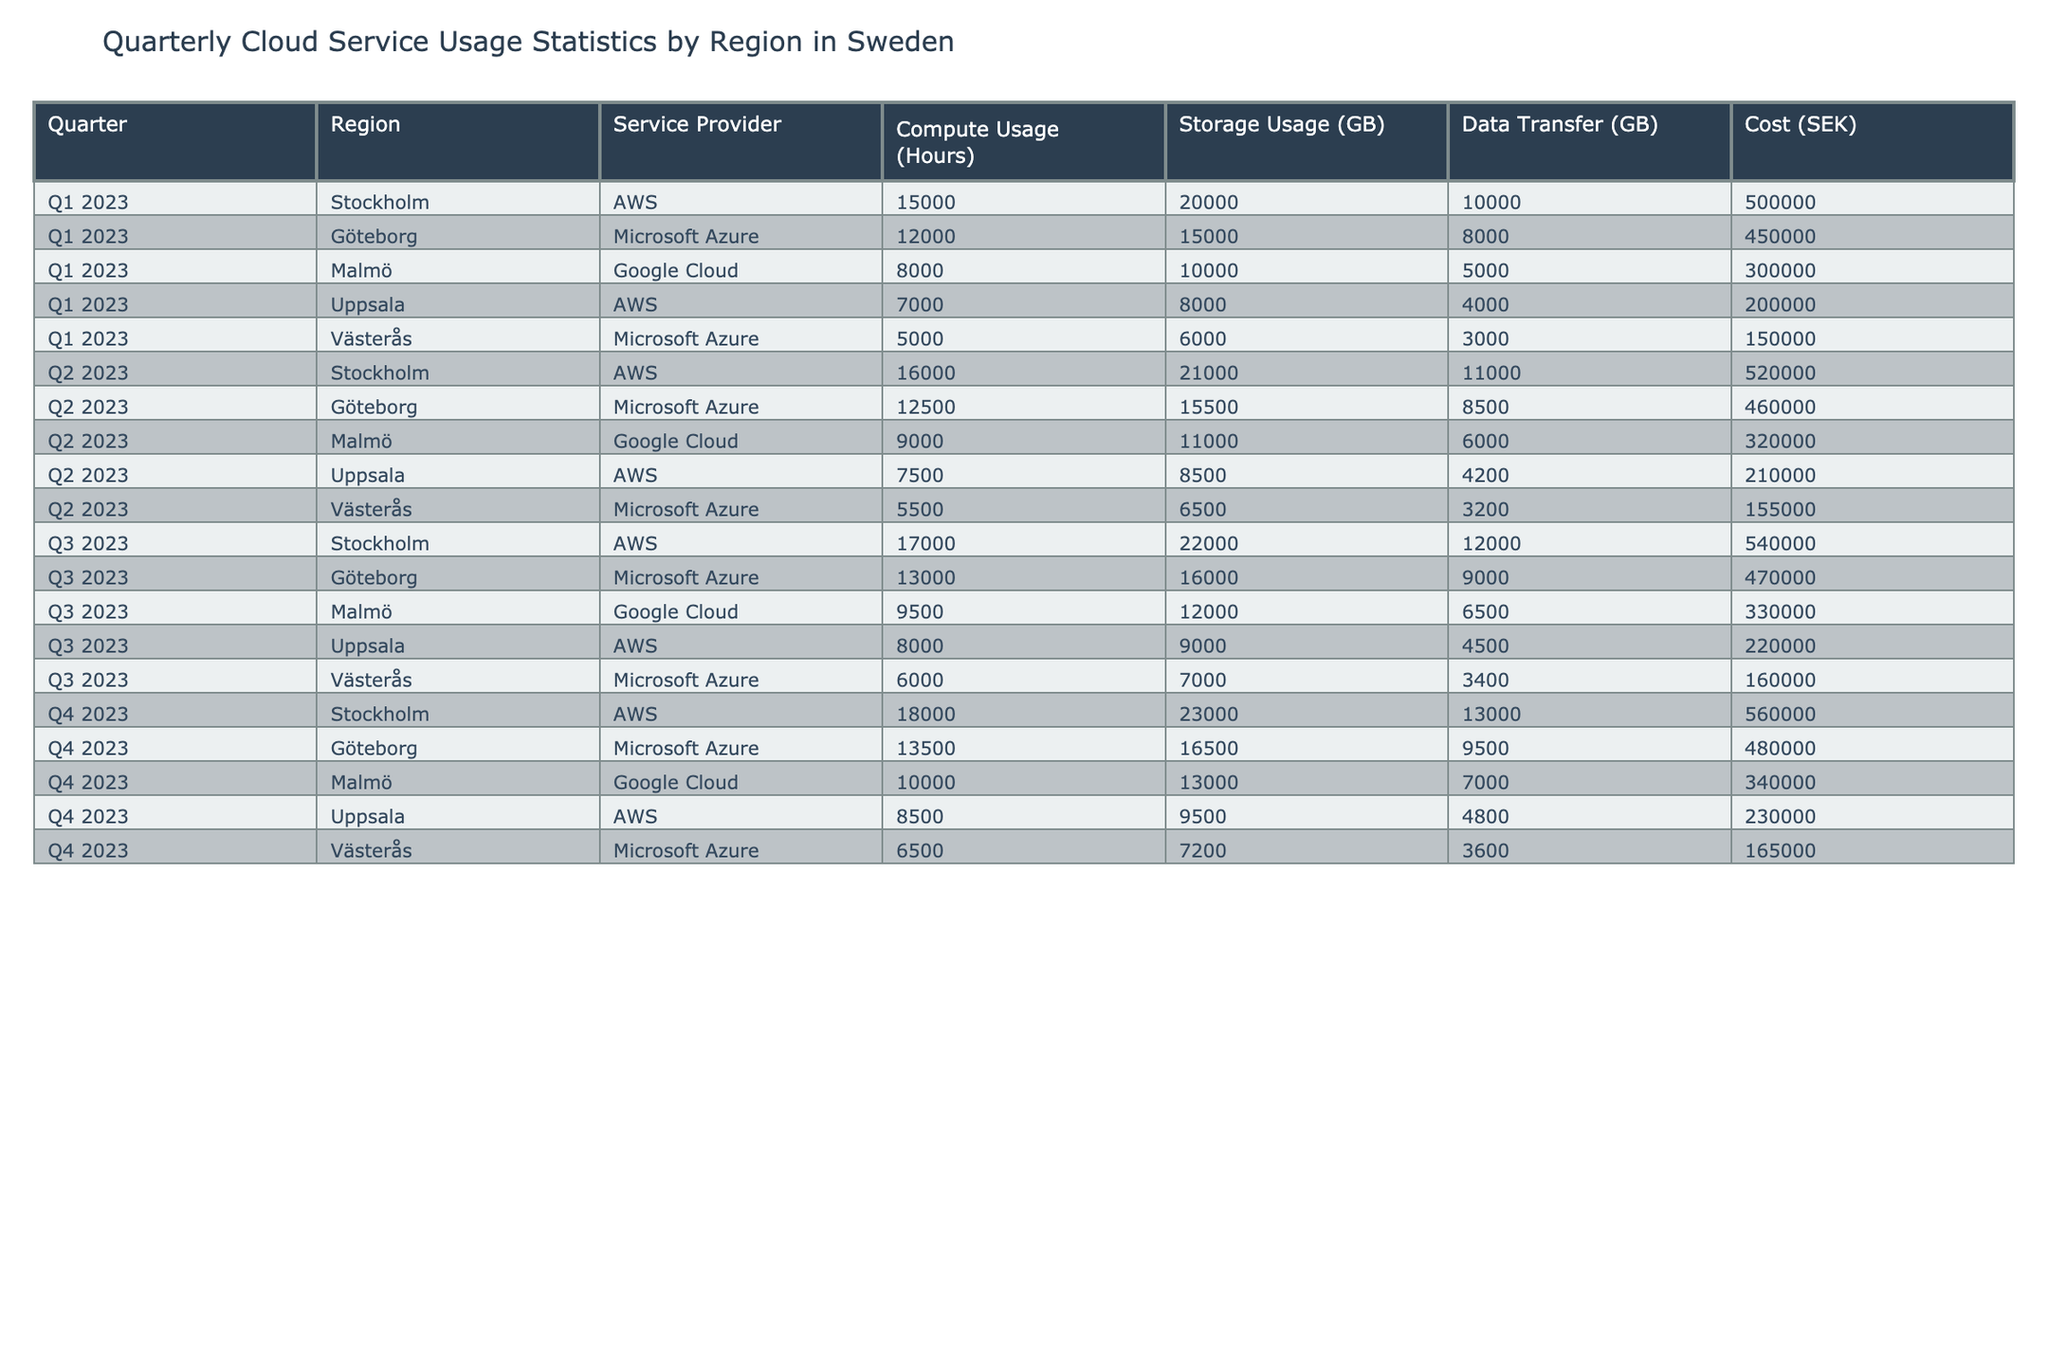What was the compute usage (in hours) for AWS in Q3 2023 in Stockholm? Referring to the table, the specific entry for compute usage under AWS in the Stockholm region for Q3 2023 is 17,000 hours.
Answer: 17,000 Which region had the highest data transfer (in GB) in Q4 2023? From the table, looking at the data transfer values in Q4 2023, Stockholm had 13,000 GB, which is the highest compared to other regions.
Answer: Stockholm What is the total cost (in SEK) for Microsoft Azure services across all regions in Q2 2023? For Microsoft Azure in Q2 2023, the costs are 460,000 SEK (Göteborg) + 155,000 SEK (Västerås) = 615,000 SEK.
Answer: 615,000 How much more compute usage (in hours) did AWS have in Q4 2023 compared to Q1 2023 in Stockholm? In Q4 2023, AWS had 18,000 hours of compute usage, and in Q1 2023, they had 15,000 hours. The difference is 18,000 - 15,000 = 3,000 hours.
Answer: 3,000 Is the storage usage (in GB) for Google Cloud in Malmö in Q3 2023 greater than the storage usage in Q1 2023? In Q3 2023, the storage usage for Google Cloud in Malmö was 12,000 GB, compared to 10,000 GB in Q1 2023. Therefore, the statement is true.
Answer: Yes What was the average data transfer (in GB) for Microsoft Azure across all quarters in Göteborg? In Göteborg, Microsoft Azure's data transfer values are: 8,500 GB (Q1) + 8,000 GB (Q2) + 9,000 GB (Q3) + 9,500 GB (Q4). The total is 35,000 GB, and the average is 35,000 / 4 = 8,750 GB.
Answer: 8,750 Which region showed the largest increase in cost (in SEK) from Q1 2023 to Q4 2023 for AWS? For AWS, the costs were 500,000 SEK in Q1 2023 (Stockholm) and 560,000 SEK in Q4 2023, a difference of 60,000 SEK. Other regions also increased, but Stockholm had the largest increase.
Answer: Stockholm Was the total compute usage (in hours) for all service providers in Uppsala greater in Q3 2023 than in Q2 2023? In Q3 2023, compute usage in Uppsala was 8,000 hours and in Q2 2023, it was 7,500 hours. Therefore, Q3 had a higher usage.
Answer: Yes What region had the lowest storage usage (in GB) in Q1 2023? In Q1 2023, Västerås had the lowest storage usage at 6,000 GB compared to other regions.
Answer: Västerås How much total data transfer (in GB) was recorded for Google Cloud across all quarters? Google Cloud data transfers are: 5,000 GB (Q1) + 6,000 GB (Q2) + 6,500 GB (Q3) + 7,000 GB (Q4) which totals 24,500 GB.
Answer: 24,500 What is the cost difference (in SEK) for Microsoft Azure from Q1 2023 to Q3 2023 in Göteborg? The cost for Microsoft Azure in Göteborg was 450,000 SEK in Q1 2023 and 470,000 SEK in Q3 2023, resulting in a difference of 20,000 SEK.
Answer: 20,000 